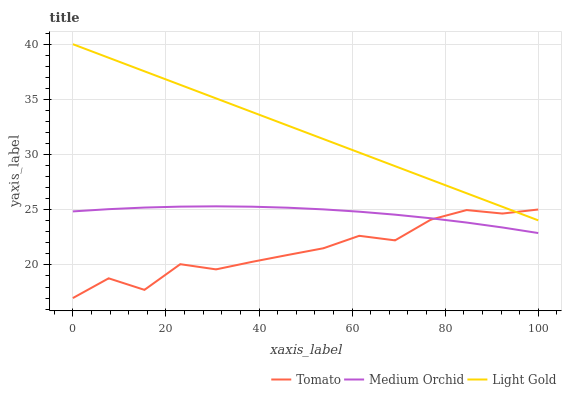Does Tomato have the minimum area under the curve?
Answer yes or no. Yes. Does Light Gold have the maximum area under the curve?
Answer yes or no. Yes. Does Medium Orchid have the minimum area under the curve?
Answer yes or no. No. Does Medium Orchid have the maximum area under the curve?
Answer yes or no. No. Is Light Gold the smoothest?
Answer yes or no. Yes. Is Tomato the roughest?
Answer yes or no. Yes. Is Medium Orchid the smoothest?
Answer yes or no. No. Is Medium Orchid the roughest?
Answer yes or no. No. Does Tomato have the lowest value?
Answer yes or no. Yes. Does Medium Orchid have the lowest value?
Answer yes or no. No. Does Light Gold have the highest value?
Answer yes or no. Yes. Does Medium Orchid have the highest value?
Answer yes or no. No. Is Medium Orchid less than Light Gold?
Answer yes or no. Yes. Is Light Gold greater than Medium Orchid?
Answer yes or no. Yes. Does Light Gold intersect Tomato?
Answer yes or no. Yes. Is Light Gold less than Tomato?
Answer yes or no. No. Is Light Gold greater than Tomato?
Answer yes or no. No. Does Medium Orchid intersect Light Gold?
Answer yes or no. No. 